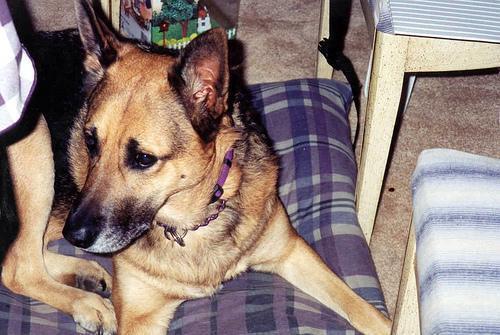How many dogs are there?
Give a very brief answer. 1. How many chairs are in the photo?
Give a very brief answer. 2. 